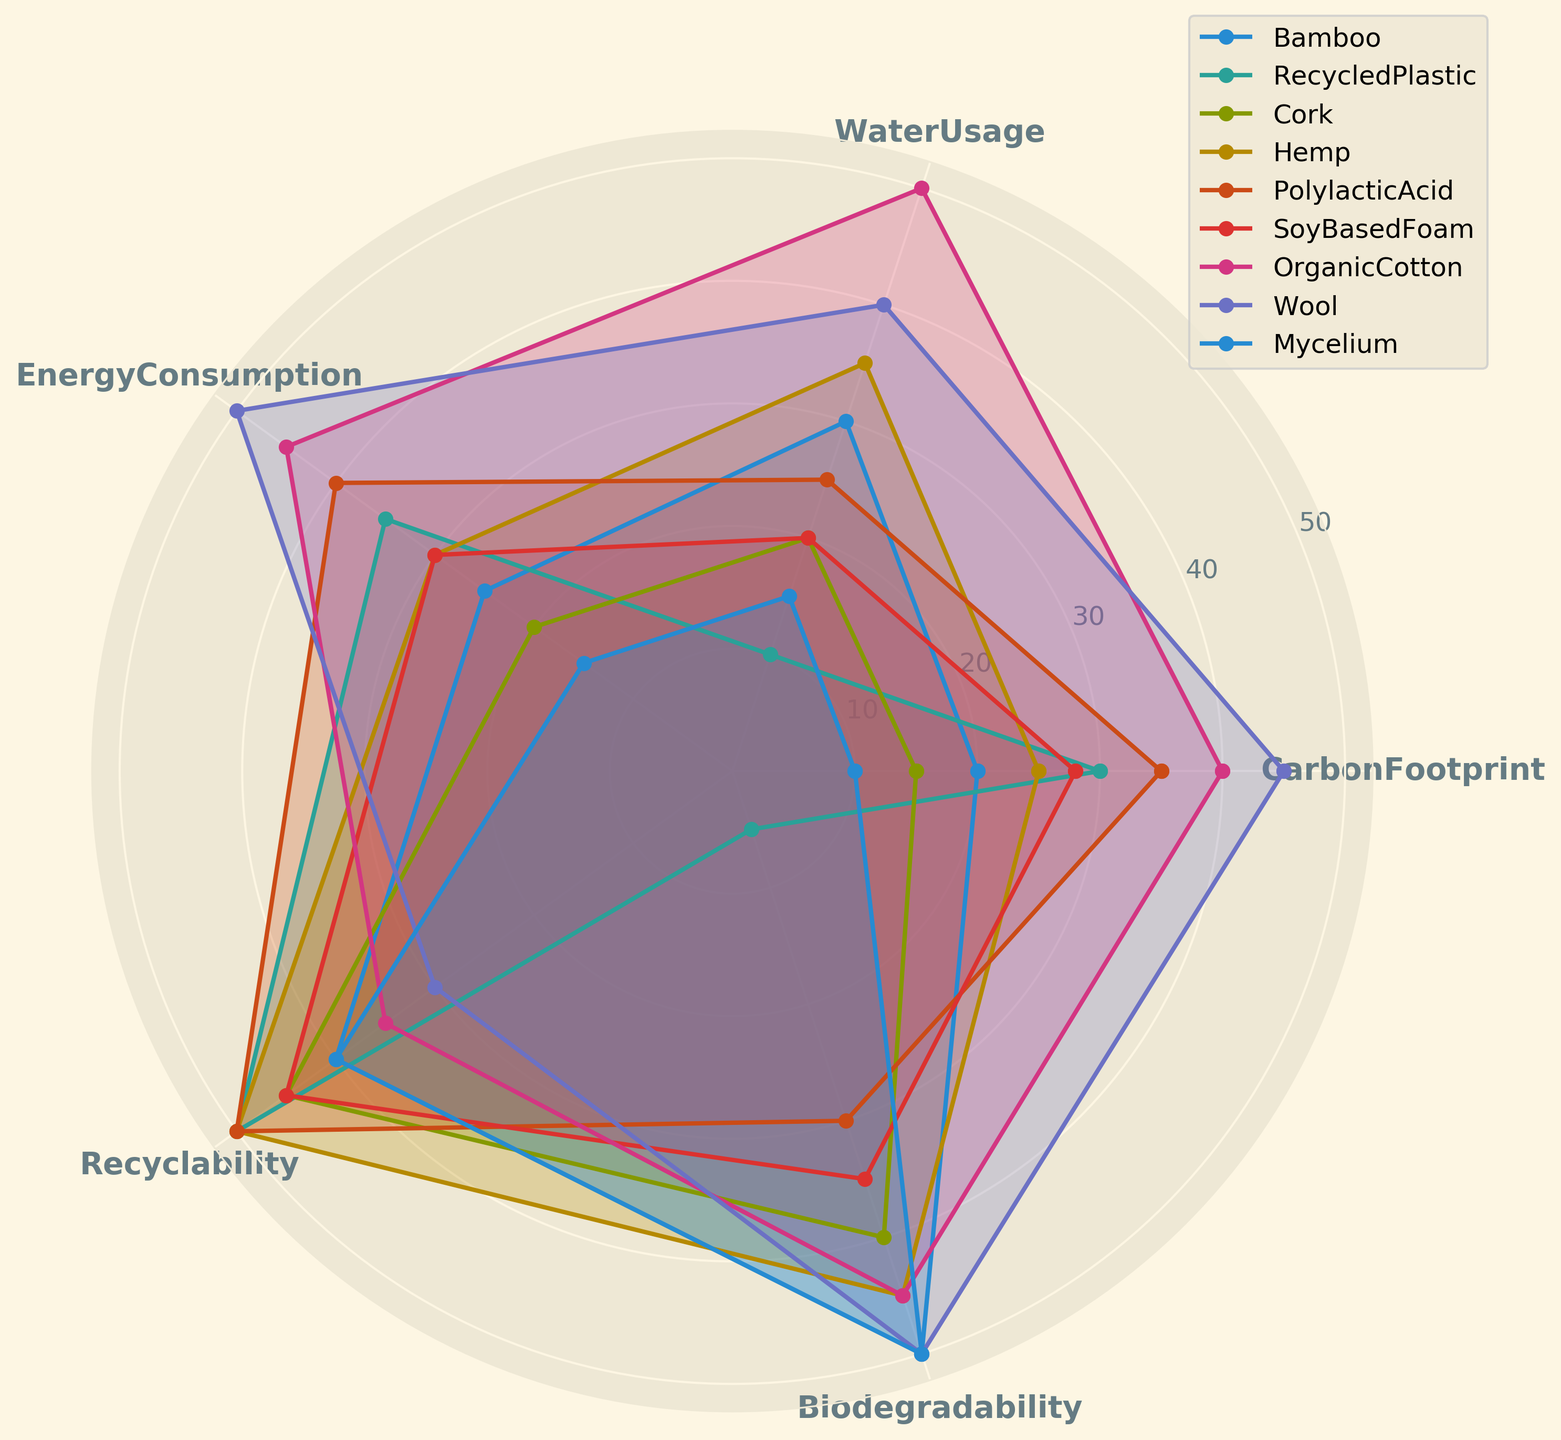What material has the lowest carbon footprint? By examining the radar chart, the material with the lowest CarbonFootprint value is the one closest to the origin at the CarbonFootprint axis. From the data, Mycelium has a carbon footprint of 10, which is the lowest among all materials.
Answer: Mycelium Between Bamboo and Organic Cotton, which has a higher energy consumption? Comparing the energy consumption values on the radar chart for Bamboo and Organic Cotton, the material that extends further from the origin on the EnergyConsumption axis has a higher value. Bamboo has an energy consumption value of 25, while Organic Cotton has a value of 45. Thus, Organic Cotton has higher energy consumption.
Answer: Organic Cotton Which material scores equally in recyclability and biodegradability? By examining the radar chart, identify the materials where the data points align equally along the Recyclability and Biodegradability axes. Both aspects for Wool value at 50, indicating it scores equally in these two factors.
Answer: Wool What's the average water usage of RecycledPlastic and Hemp? The WaterUsage values from the radar chart for RecycledPlastic and Hemp are 10 and 35, respectively. The average of these two values is calculated as (10 + 35) / 2 = 22.5.
Answer: 22.5 Which material has the highest overall scores across all environmental impact factors? By visually summarizing the coverage area of each material on the radar chart, the material with data points consistently longer from the origin across all factors will have the highest overall score. Organic Cotton tends to have high values in all categories.
Answer: Organic Cotton How many materials have a water usage value greater than 30? By scanning the radar chart and looking at the WaterUsage axis, count the materials whose data points extend beyond the 30 mark. The materials that meet this criterion are Hemp and Organic Cotton. Therefore, two materials have a water usage value greater than 30.
Answer: 2 What is the difference in carbon footprint between Cork and Soy Based Foam? On the radar chart, look at the CarbonFootprint axis to find the values for Cork (15) and Soy Based Foam (28). The difference is calculated as 28 - 15 = 13.
Answer: 13 Is there any material that has a biodegradability score equal to its energy consumption score? By inspecting the radar chart and comparing the data points on the Biodegradability and EnergyConsumption axes, one can see that no material has an identical score for these two axes.
Answer: No 